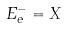<formula> <loc_0><loc_0><loc_500><loc_500>E _ { e } ^ { - } = X</formula> 